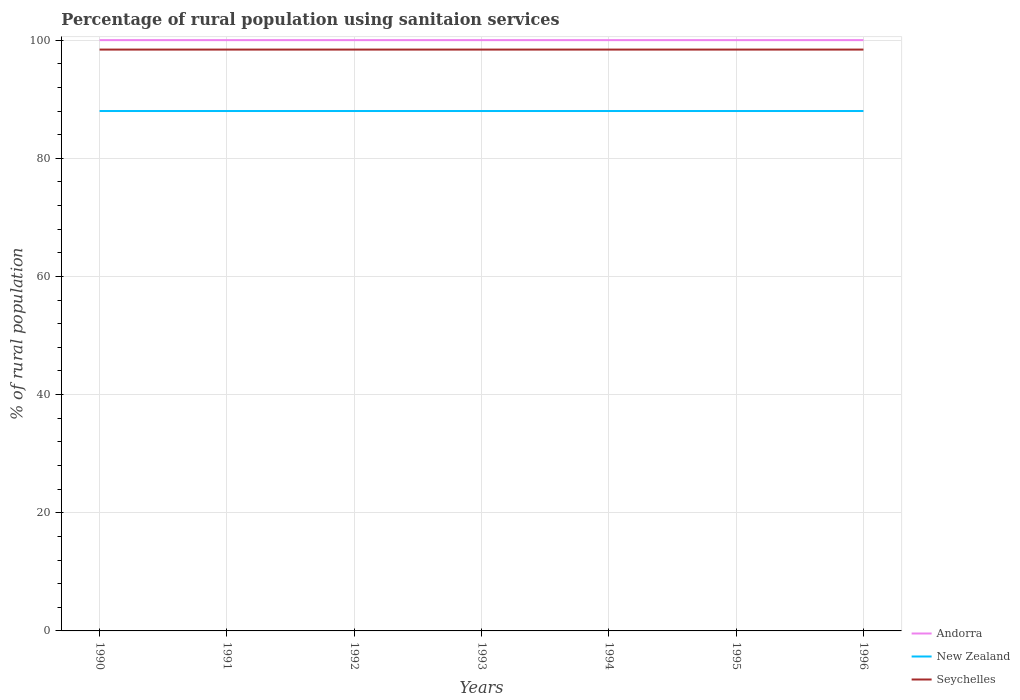How many different coloured lines are there?
Ensure brevity in your answer.  3. Is the number of lines equal to the number of legend labels?
Make the answer very short. Yes. Across all years, what is the maximum percentage of rural population using sanitaion services in Seychelles?
Give a very brief answer. 98.4. What is the difference between the highest and the lowest percentage of rural population using sanitaion services in New Zealand?
Your answer should be very brief. 0. Is the percentage of rural population using sanitaion services in New Zealand strictly greater than the percentage of rural population using sanitaion services in Seychelles over the years?
Provide a short and direct response. Yes. How many lines are there?
Give a very brief answer. 3. How many years are there in the graph?
Give a very brief answer. 7. What is the difference between two consecutive major ticks on the Y-axis?
Your response must be concise. 20. Does the graph contain grids?
Your response must be concise. Yes. Where does the legend appear in the graph?
Your response must be concise. Bottom right. What is the title of the graph?
Offer a very short reply. Percentage of rural population using sanitaion services. Does "Equatorial Guinea" appear as one of the legend labels in the graph?
Ensure brevity in your answer.  No. What is the label or title of the X-axis?
Provide a short and direct response. Years. What is the label or title of the Y-axis?
Offer a very short reply. % of rural population. What is the % of rural population in Andorra in 1990?
Provide a succinct answer. 100. What is the % of rural population in Seychelles in 1990?
Make the answer very short. 98.4. What is the % of rural population of Seychelles in 1991?
Offer a terse response. 98.4. What is the % of rural population of Andorra in 1992?
Ensure brevity in your answer.  100. What is the % of rural population of New Zealand in 1992?
Ensure brevity in your answer.  88. What is the % of rural population in Seychelles in 1992?
Make the answer very short. 98.4. What is the % of rural population of Seychelles in 1993?
Provide a short and direct response. 98.4. What is the % of rural population of Andorra in 1994?
Your answer should be compact. 100. What is the % of rural population of New Zealand in 1994?
Offer a terse response. 88. What is the % of rural population of Seychelles in 1994?
Keep it short and to the point. 98.4. What is the % of rural population of Andorra in 1995?
Offer a very short reply. 100. What is the % of rural population of New Zealand in 1995?
Your answer should be compact. 88. What is the % of rural population in Seychelles in 1995?
Your response must be concise. 98.4. What is the % of rural population of Andorra in 1996?
Provide a short and direct response. 100. What is the % of rural population of New Zealand in 1996?
Make the answer very short. 88. What is the % of rural population in Seychelles in 1996?
Offer a terse response. 98.4. Across all years, what is the maximum % of rural population of Seychelles?
Your answer should be very brief. 98.4. Across all years, what is the minimum % of rural population in Andorra?
Provide a succinct answer. 100. Across all years, what is the minimum % of rural population in Seychelles?
Offer a terse response. 98.4. What is the total % of rural population in Andorra in the graph?
Keep it short and to the point. 700. What is the total % of rural population of New Zealand in the graph?
Ensure brevity in your answer.  616. What is the total % of rural population of Seychelles in the graph?
Your answer should be very brief. 688.8. What is the difference between the % of rural population in Andorra in 1990 and that in 1991?
Offer a very short reply. 0. What is the difference between the % of rural population in Andorra in 1990 and that in 1992?
Offer a very short reply. 0. What is the difference between the % of rural population in Seychelles in 1990 and that in 1992?
Your answer should be compact. 0. What is the difference between the % of rural population of New Zealand in 1990 and that in 1993?
Your answer should be compact. 0. What is the difference between the % of rural population of Seychelles in 1990 and that in 1993?
Your response must be concise. 0. What is the difference between the % of rural population of Seychelles in 1990 and that in 1994?
Offer a very short reply. 0. What is the difference between the % of rural population in Andorra in 1990 and that in 1996?
Offer a very short reply. 0. What is the difference between the % of rural population in Seychelles in 1990 and that in 1996?
Provide a short and direct response. 0. What is the difference between the % of rural population in Andorra in 1991 and that in 1992?
Provide a succinct answer. 0. What is the difference between the % of rural population of New Zealand in 1991 and that in 1992?
Ensure brevity in your answer.  0. What is the difference between the % of rural population of Andorra in 1991 and that in 1993?
Your answer should be very brief. 0. What is the difference between the % of rural population in Andorra in 1991 and that in 1994?
Your response must be concise. 0. What is the difference between the % of rural population of New Zealand in 1991 and that in 1994?
Provide a short and direct response. 0. What is the difference between the % of rural population in Andorra in 1991 and that in 1995?
Your answer should be compact. 0. What is the difference between the % of rural population in New Zealand in 1991 and that in 1995?
Your answer should be very brief. 0. What is the difference between the % of rural population of New Zealand in 1992 and that in 1993?
Make the answer very short. 0. What is the difference between the % of rural population of Andorra in 1992 and that in 1994?
Keep it short and to the point. 0. What is the difference between the % of rural population of Seychelles in 1992 and that in 1994?
Provide a short and direct response. 0. What is the difference between the % of rural population in Andorra in 1992 and that in 1995?
Give a very brief answer. 0. What is the difference between the % of rural population in New Zealand in 1992 and that in 1995?
Provide a short and direct response. 0. What is the difference between the % of rural population in Seychelles in 1992 and that in 1995?
Offer a very short reply. 0. What is the difference between the % of rural population in New Zealand in 1992 and that in 1996?
Provide a succinct answer. 0. What is the difference between the % of rural population of New Zealand in 1994 and that in 1995?
Keep it short and to the point. 0. What is the difference between the % of rural population of Seychelles in 1994 and that in 1995?
Make the answer very short. 0. What is the difference between the % of rural population of Andorra in 1994 and that in 1996?
Ensure brevity in your answer.  0. What is the difference between the % of rural population of Andorra in 1995 and that in 1996?
Your answer should be compact. 0. What is the difference between the % of rural population in New Zealand in 1995 and that in 1996?
Offer a terse response. 0. What is the difference between the % of rural population of Seychelles in 1995 and that in 1996?
Make the answer very short. 0. What is the difference between the % of rural population of Andorra in 1990 and the % of rural population of New Zealand in 1991?
Provide a succinct answer. 12. What is the difference between the % of rural population in Andorra in 1990 and the % of rural population in Seychelles in 1991?
Keep it short and to the point. 1.6. What is the difference between the % of rural population in Andorra in 1990 and the % of rural population in New Zealand in 1992?
Keep it short and to the point. 12. What is the difference between the % of rural population of Andorra in 1990 and the % of rural population of Seychelles in 1992?
Your answer should be very brief. 1.6. What is the difference between the % of rural population in New Zealand in 1990 and the % of rural population in Seychelles in 1992?
Provide a short and direct response. -10.4. What is the difference between the % of rural population of New Zealand in 1990 and the % of rural population of Seychelles in 1993?
Provide a short and direct response. -10.4. What is the difference between the % of rural population of Andorra in 1990 and the % of rural population of New Zealand in 1994?
Offer a terse response. 12. What is the difference between the % of rural population of Andorra in 1990 and the % of rural population of Seychelles in 1994?
Your answer should be compact. 1.6. What is the difference between the % of rural population in New Zealand in 1990 and the % of rural population in Seychelles in 1994?
Your answer should be very brief. -10.4. What is the difference between the % of rural population in Andorra in 1990 and the % of rural population in New Zealand in 1995?
Provide a short and direct response. 12. What is the difference between the % of rural population in Andorra in 1990 and the % of rural population in Seychelles in 1995?
Your answer should be very brief. 1.6. What is the difference between the % of rural population of Andorra in 1990 and the % of rural population of New Zealand in 1996?
Provide a succinct answer. 12. What is the difference between the % of rural population of Andorra in 1991 and the % of rural population of New Zealand in 1992?
Your answer should be very brief. 12. What is the difference between the % of rural population in Andorra in 1991 and the % of rural population in Seychelles in 1992?
Your response must be concise. 1.6. What is the difference between the % of rural population of New Zealand in 1991 and the % of rural population of Seychelles in 1992?
Offer a very short reply. -10.4. What is the difference between the % of rural population of Andorra in 1991 and the % of rural population of New Zealand in 1993?
Your answer should be very brief. 12. What is the difference between the % of rural population of Andorra in 1991 and the % of rural population of Seychelles in 1993?
Provide a short and direct response. 1.6. What is the difference between the % of rural population of Andorra in 1991 and the % of rural population of New Zealand in 1994?
Make the answer very short. 12. What is the difference between the % of rural population in Andorra in 1991 and the % of rural population in Seychelles in 1994?
Your answer should be very brief. 1.6. What is the difference between the % of rural population of Andorra in 1991 and the % of rural population of New Zealand in 1995?
Your response must be concise. 12. What is the difference between the % of rural population of New Zealand in 1991 and the % of rural population of Seychelles in 1996?
Provide a short and direct response. -10.4. What is the difference between the % of rural population in Andorra in 1992 and the % of rural population in Seychelles in 1993?
Your response must be concise. 1.6. What is the difference between the % of rural population in Andorra in 1992 and the % of rural population in New Zealand in 1994?
Ensure brevity in your answer.  12. What is the difference between the % of rural population in Andorra in 1992 and the % of rural population in Seychelles in 1995?
Provide a short and direct response. 1.6. What is the difference between the % of rural population in New Zealand in 1992 and the % of rural population in Seychelles in 1995?
Offer a terse response. -10.4. What is the difference between the % of rural population in Andorra in 1993 and the % of rural population in New Zealand in 1995?
Give a very brief answer. 12. What is the difference between the % of rural population of New Zealand in 1993 and the % of rural population of Seychelles in 1995?
Give a very brief answer. -10.4. What is the difference between the % of rural population in Andorra in 1993 and the % of rural population in Seychelles in 1996?
Keep it short and to the point. 1.6. What is the difference between the % of rural population of Andorra in 1994 and the % of rural population of New Zealand in 1996?
Ensure brevity in your answer.  12. What is the difference between the % of rural population in Andorra in 1994 and the % of rural population in Seychelles in 1996?
Give a very brief answer. 1.6. What is the average % of rural population of Andorra per year?
Provide a succinct answer. 100. What is the average % of rural population in Seychelles per year?
Your response must be concise. 98.4. In the year 1990, what is the difference between the % of rural population in Andorra and % of rural population in Seychelles?
Ensure brevity in your answer.  1.6. In the year 1990, what is the difference between the % of rural population of New Zealand and % of rural population of Seychelles?
Give a very brief answer. -10.4. In the year 1992, what is the difference between the % of rural population in Andorra and % of rural population in New Zealand?
Your answer should be very brief. 12. In the year 1992, what is the difference between the % of rural population in New Zealand and % of rural population in Seychelles?
Provide a short and direct response. -10.4. In the year 1993, what is the difference between the % of rural population in Andorra and % of rural population in New Zealand?
Offer a terse response. 12. In the year 1993, what is the difference between the % of rural population in New Zealand and % of rural population in Seychelles?
Provide a short and direct response. -10.4. In the year 1994, what is the difference between the % of rural population of Andorra and % of rural population of New Zealand?
Provide a succinct answer. 12. In the year 1994, what is the difference between the % of rural population of New Zealand and % of rural population of Seychelles?
Keep it short and to the point. -10.4. In the year 1995, what is the difference between the % of rural population of Andorra and % of rural population of New Zealand?
Make the answer very short. 12. In the year 1995, what is the difference between the % of rural population of New Zealand and % of rural population of Seychelles?
Your response must be concise. -10.4. In the year 1996, what is the difference between the % of rural population of Andorra and % of rural population of New Zealand?
Offer a very short reply. 12. What is the ratio of the % of rural population of New Zealand in 1990 to that in 1991?
Provide a short and direct response. 1. What is the ratio of the % of rural population of Andorra in 1990 to that in 1992?
Provide a short and direct response. 1. What is the ratio of the % of rural population of Seychelles in 1990 to that in 1992?
Provide a short and direct response. 1. What is the ratio of the % of rural population in Seychelles in 1990 to that in 1993?
Provide a short and direct response. 1. What is the ratio of the % of rural population in Andorra in 1990 to that in 1994?
Give a very brief answer. 1. What is the ratio of the % of rural population in Seychelles in 1990 to that in 1994?
Your answer should be compact. 1. What is the ratio of the % of rural population of New Zealand in 1990 to that in 1995?
Make the answer very short. 1. What is the ratio of the % of rural population in Andorra in 1990 to that in 1996?
Give a very brief answer. 1. What is the ratio of the % of rural population in New Zealand in 1990 to that in 1996?
Keep it short and to the point. 1. What is the ratio of the % of rural population in Seychelles in 1990 to that in 1996?
Your response must be concise. 1. What is the ratio of the % of rural population in Andorra in 1991 to that in 1992?
Offer a very short reply. 1. What is the ratio of the % of rural population of Seychelles in 1991 to that in 1992?
Your answer should be compact. 1. What is the ratio of the % of rural population in Andorra in 1991 to that in 1993?
Give a very brief answer. 1. What is the ratio of the % of rural population of New Zealand in 1991 to that in 1993?
Provide a succinct answer. 1. What is the ratio of the % of rural population of Seychelles in 1991 to that in 1993?
Your answer should be very brief. 1. What is the ratio of the % of rural population in New Zealand in 1991 to that in 1994?
Offer a terse response. 1. What is the ratio of the % of rural population in New Zealand in 1991 to that in 1995?
Give a very brief answer. 1. What is the ratio of the % of rural population of New Zealand in 1991 to that in 1996?
Offer a terse response. 1. What is the ratio of the % of rural population of Andorra in 1992 to that in 1993?
Make the answer very short. 1. What is the ratio of the % of rural population in New Zealand in 1992 to that in 1993?
Give a very brief answer. 1. What is the ratio of the % of rural population in Seychelles in 1992 to that in 1993?
Your answer should be very brief. 1. What is the ratio of the % of rural population of Andorra in 1992 to that in 1994?
Offer a terse response. 1. What is the ratio of the % of rural population of Seychelles in 1992 to that in 1994?
Ensure brevity in your answer.  1. What is the ratio of the % of rural population in New Zealand in 1992 to that in 1996?
Provide a succinct answer. 1. What is the ratio of the % of rural population in Seychelles in 1992 to that in 1996?
Provide a short and direct response. 1. What is the ratio of the % of rural population in Andorra in 1993 to that in 1994?
Offer a very short reply. 1. What is the ratio of the % of rural population of New Zealand in 1993 to that in 1994?
Provide a short and direct response. 1. What is the ratio of the % of rural population of Seychelles in 1993 to that in 1994?
Provide a short and direct response. 1. What is the ratio of the % of rural population in Andorra in 1993 to that in 1995?
Keep it short and to the point. 1. What is the ratio of the % of rural population of New Zealand in 1993 to that in 1995?
Your answer should be compact. 1. What is the ratio of the % of rural population in Andorra in 1993 to that in 1996?
Make the answer very short. 1. What is the ratio of the % of rural population of New Zealand in 1993 to that in 1996?
Give a very brief answer. 1. What is the ratio of the % of rural population of Seychelles in 1993 to that in 1996?
Offer a terse response. 1. What is the ratio of the % of rural population in Andorra in 1994 to that in 1995?
Your answer should be compact. 1. What is the ratio of the % of rural population in Andorra in 1994 to that in 1996?
Your answer should be compact. 1. What is the ratio of the % of rural population in Seychelles in 1994 to that in 1996?
Give a very brief answer. 1. What is the ratio of the % of rural population of Andorra in 1995 to that in 1996?
Offer a terse response. 1. What is the ratio of the % of rural population of Seychelles in 1995 to that in 1996?
Offer a terse response. 1. What is the difference between the highest and the second highest % of rural population in Andorra?
Offer a terse response. 0. What is the difference between the highest and the second highest % of rural population in New Zealand?
Ensure brevity in your answer.  0. What is the difference between the highest and the second highest % of rural population in Seychelles?
Your answer should be very brief. 0. What is the difference between the highest and the lowest % of rural population in Andorra?
Make the answer very short. 0. What is the difference between the highest and the lowest % of rural population of New Zealand?
Offer a terse response. 0. 